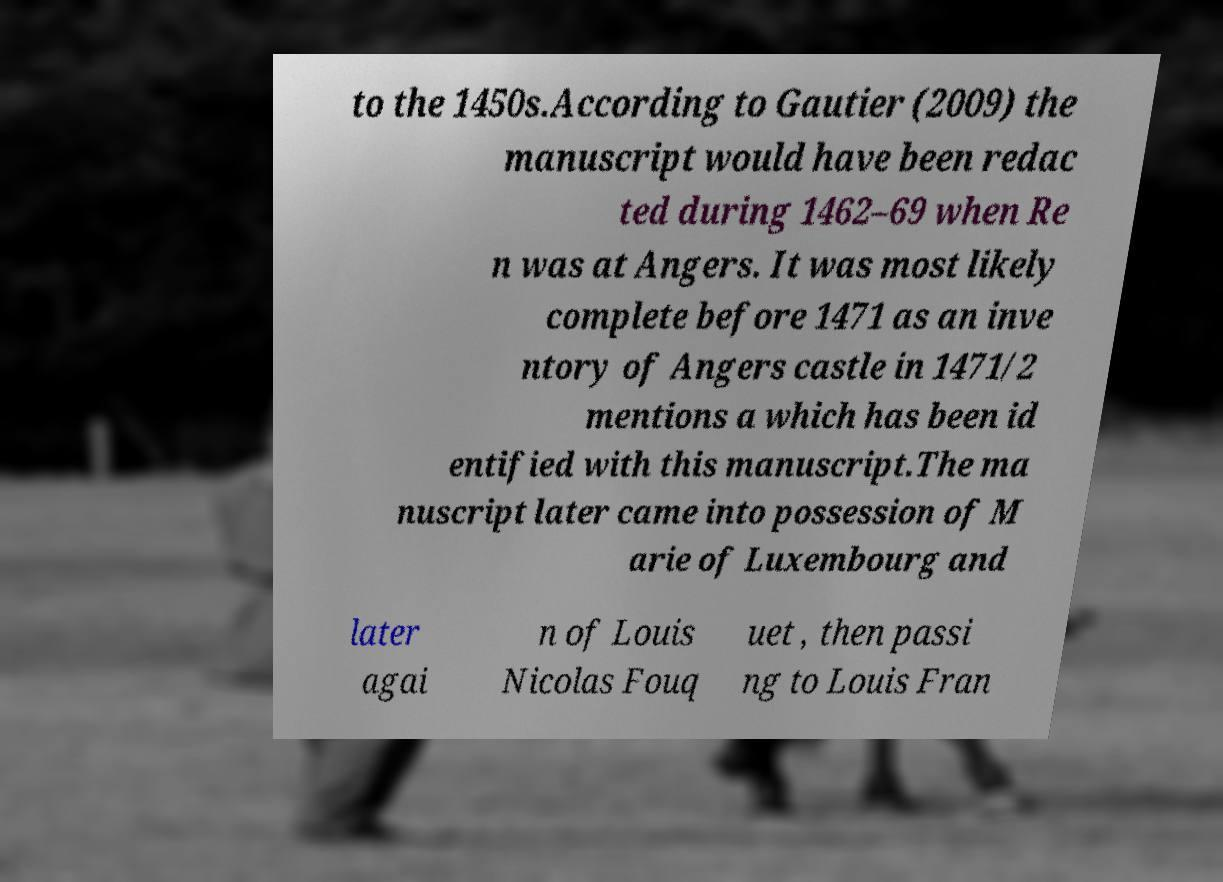Please read and relay the text visible in this image. What does it say? to the 1450s.According to Gautier (2009) the manuscript would have been redac ted during 1462–69 when Re n was at Angers. It was most likely complete before 1471 as an inve ntory of Angers castle in 1471/2 mentions a which has been id entified with this manuscript.The ma nuscript later came into possession of M arie of Luxembourg and later agai n of Louis Nicolas Fouq uet , then passi ng to Louis Fran 